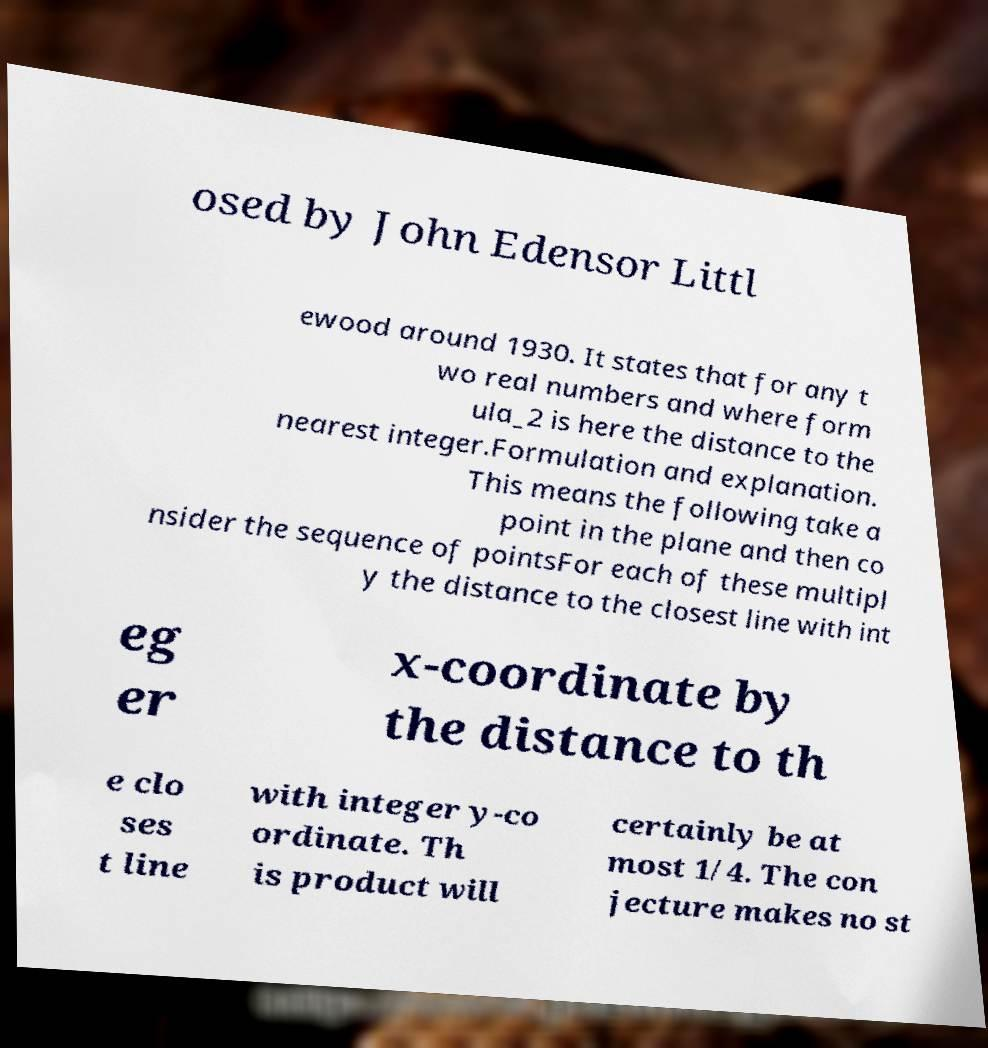For documentation purposes, I need the text within this image transcribed. Could you provide that? osed by John Edensor Littl ewood around 1930. It states that for any t wo real numbers and where form ula_2 is here the distance to the nearest integer.Formulation and explanation. This means the following take a point in the plane and then co nsider the sequence of pointsFor each of these multipl y the distance to the closest line with int eg er x-coordinate by the distance to th e clo ses t line with integer y-co ordinate. Th is product will certainly be at most 1/4. The con jecture makes no st 